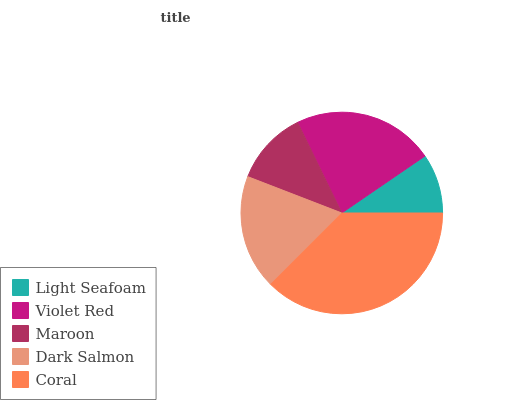Is Light Seafoam the minimum?
Answer yes or no. Yes. Is Coral the maximum?
Answer yes or no. Yes. Is Violet Red the minimum?
Answer yes or no. No. Is Violet Red the maximum?
Answer yes or no. No. Is Violet Red greater than Light Seafoam?
Answer yes or no. Yes. Is Light Seafoam less than Violet Red?
Answer yes or no. Yes. Is Light Seafoam greater than Violet Red?
Answer yes or no. No. Is Violet Red less than Light Seafoam?
Answer yes or no. No. Is Dark Salmon the high median?
Answer yes or no. Yes. Is Dark Salmon the low median?
Answer yes or no. Yes. Is Light Seafoam the high median?
Answer yes or no. No. Is Maroon the low median?
Answer yes or no. No. 